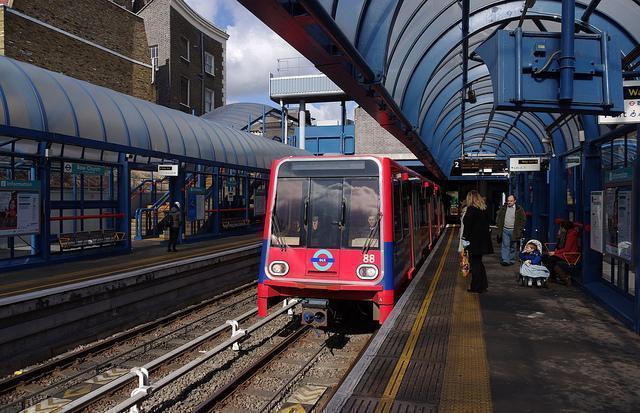Why are they all looking at the train?
Indicate the correct response by choosing from the four available options to answer the question.
Options: Fearful, want ride, annoyed, like colors. Want ride. 